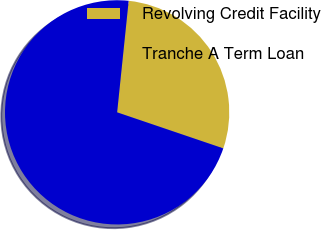Convert chart. <chart><loc_0><loc_0><loc_500><loc_500><pie_chart><fcel>Revolving Credit Facility<fcel>Tranche A Term Loan<nl><fcel>28.57%<fcel>71.43%<nl></chart> 